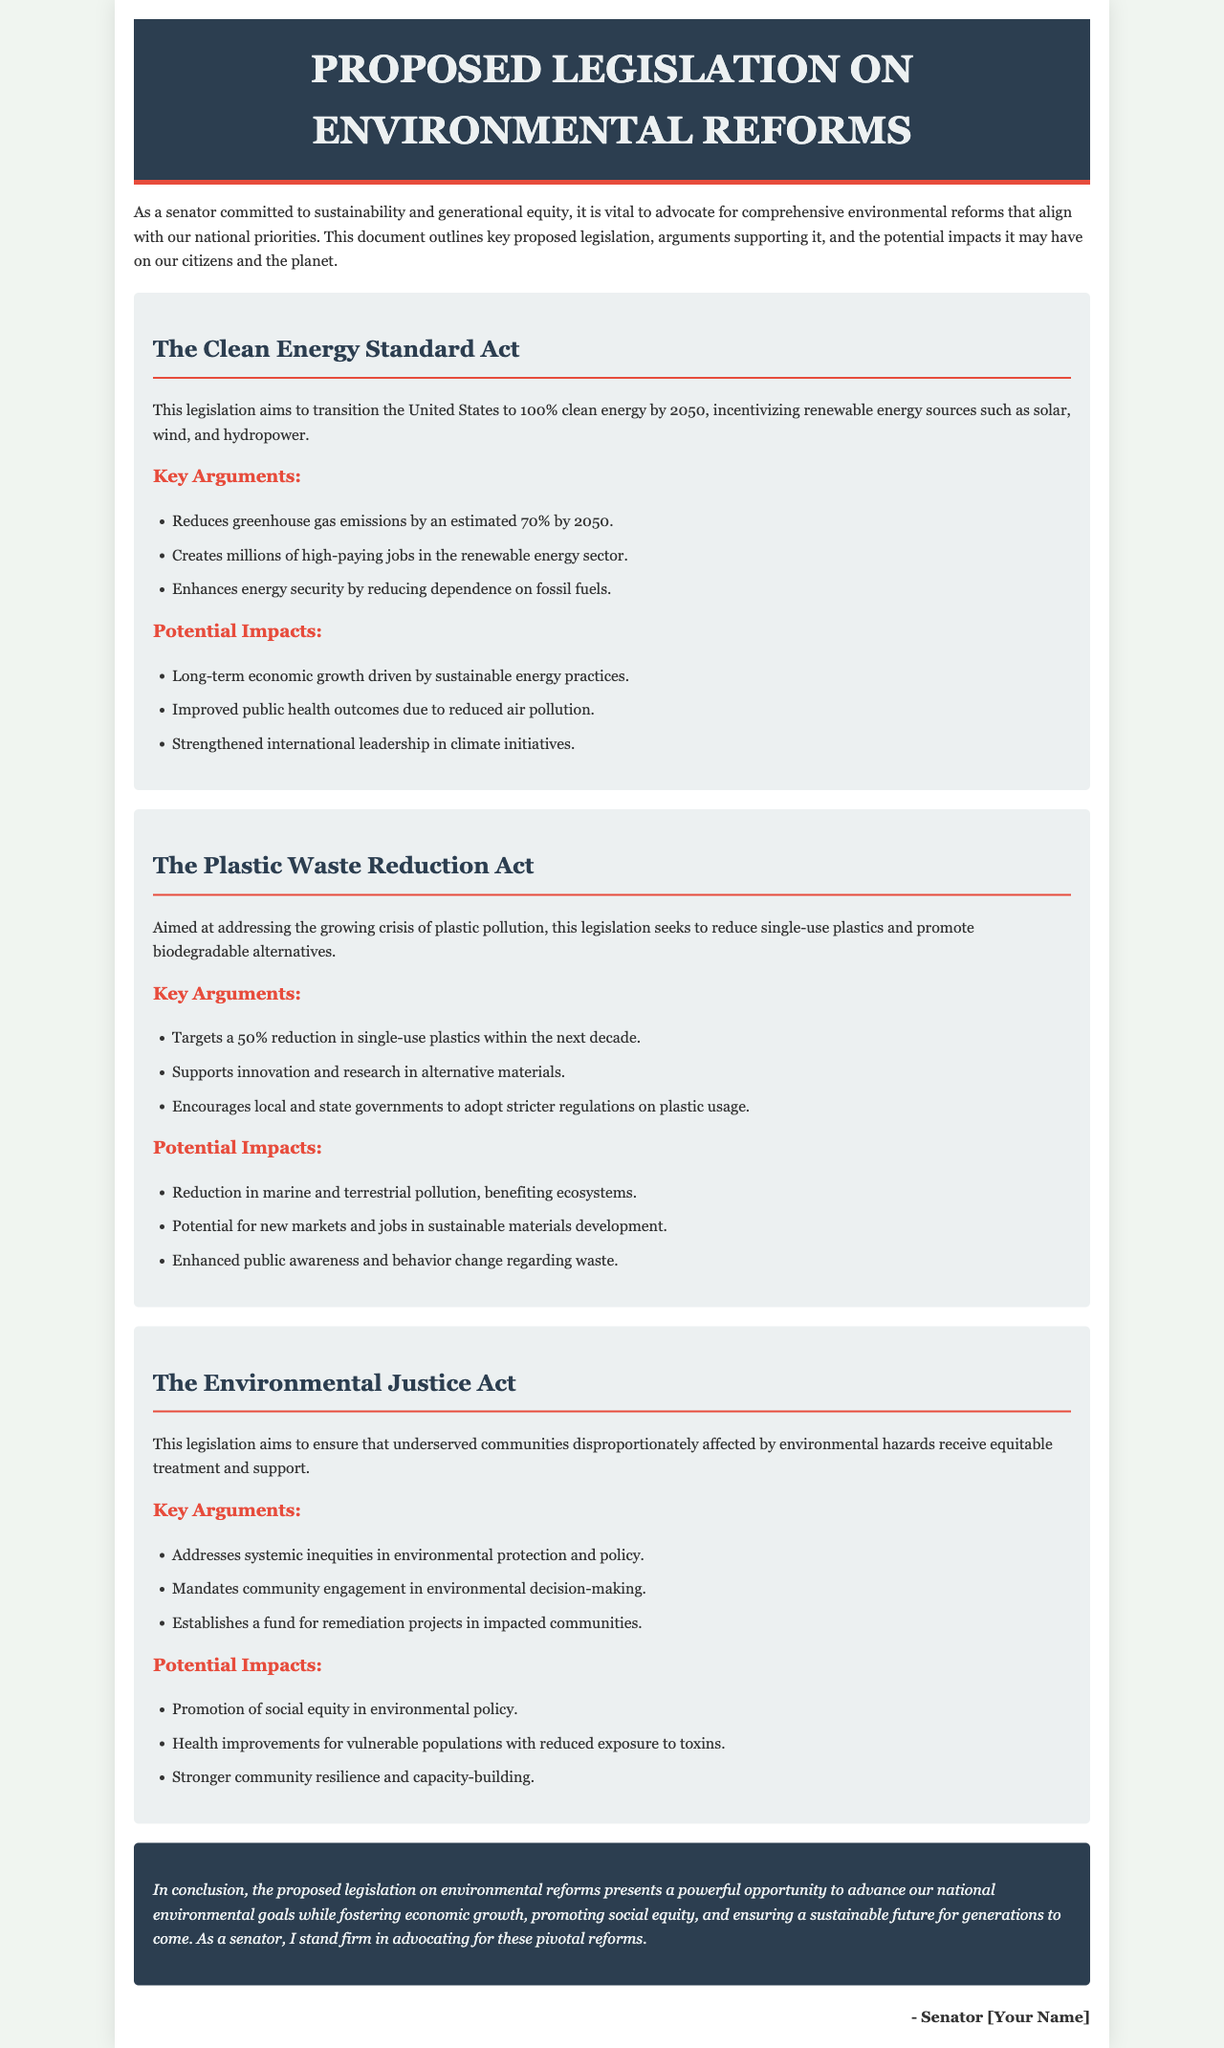What is the title of the proposed legislation? The title is stated prominently at the top of the document.
Answer: Proposed Legislation on Environmental Reforms How many key arguments are listed for the Clean Energy Standard Act? The section mentions key arguments specifically under this act.
Answer: Three What is the target year for achieving 100% clean energy in the Clean Energy Standard Act? The legislation specifies a target for this initiative.
Answer: 2050 What percentage reduction in single-use plastics does the Plastic Waste Reduction Act aim for? The act outlines a specific goal regarding single-use plastics.
Answer: 50% What does the Environmental Justice Act establish for impacted communities? The act mentions a specific type of support system for affected groups.
Answer: A fund for remediation projects What long-term economic benefit is associated with the Clean Energy Standard Act? The legislation outlines various potential impacts, including economic benefits.
Answer: Long-term economic growth Who benefits from the promotion of social equity in environmental policy under the Environmental Justice Act? The act highlights the focus on certain community types affected by environmental issues.
Answer: Vulnerable populations What is a key impact of the Plastic Waste Reduction Act on ecosystems? The document outlines the potential environmental outcomes of this act.
Answer: Reduction in marine and terrestrial pollution What does the Clean Energy Standard Act enhance in terms of energy sources? The act promotes a specific transformation in how energy is sourced.
Answer: Energy security 